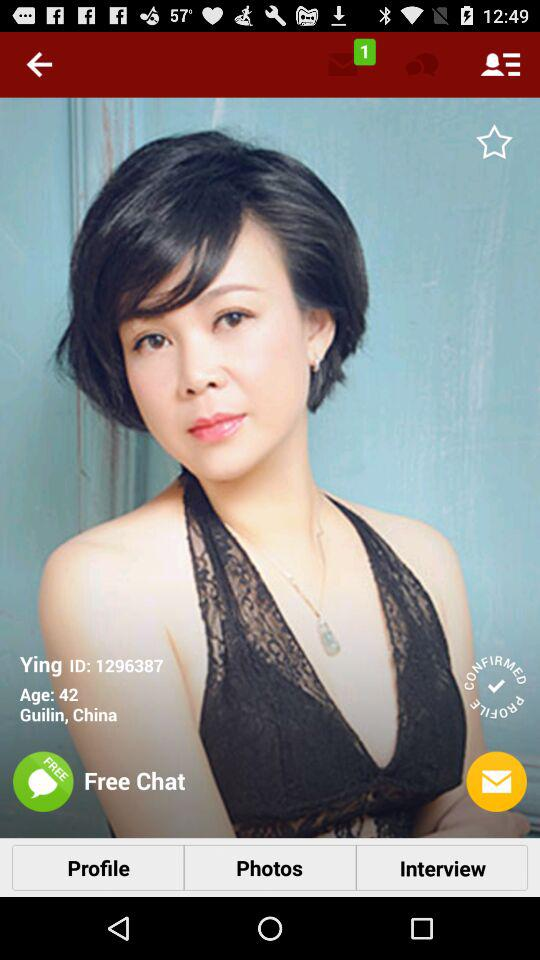What is the name? The name is Ying. 